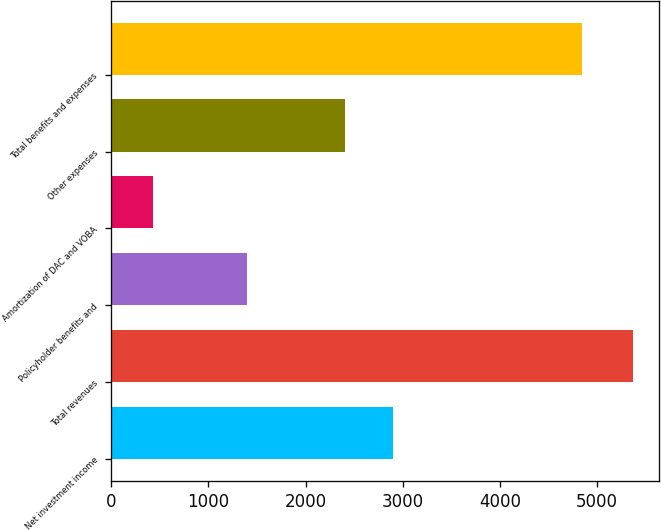Convert chart. <chart><loc_0><loc_0><loc_500><loc_500><bar_chart><fcel>Net investment income<fcel>Total revenues<fcel>Policyholder benefits and<fcel>Amortization of DAC and VOBA<fcel>Other expenses<fcel>Total benefits and expenses<nl><fcel>2899.2<fcel>5366<fcel>1398<fcel>424<fcel>2405<fcel>4847<nl></chart> 